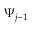<formula> <loc_0><loc_0><loc_500><loc_500>\Psi _ { j - 1 }</formula> 